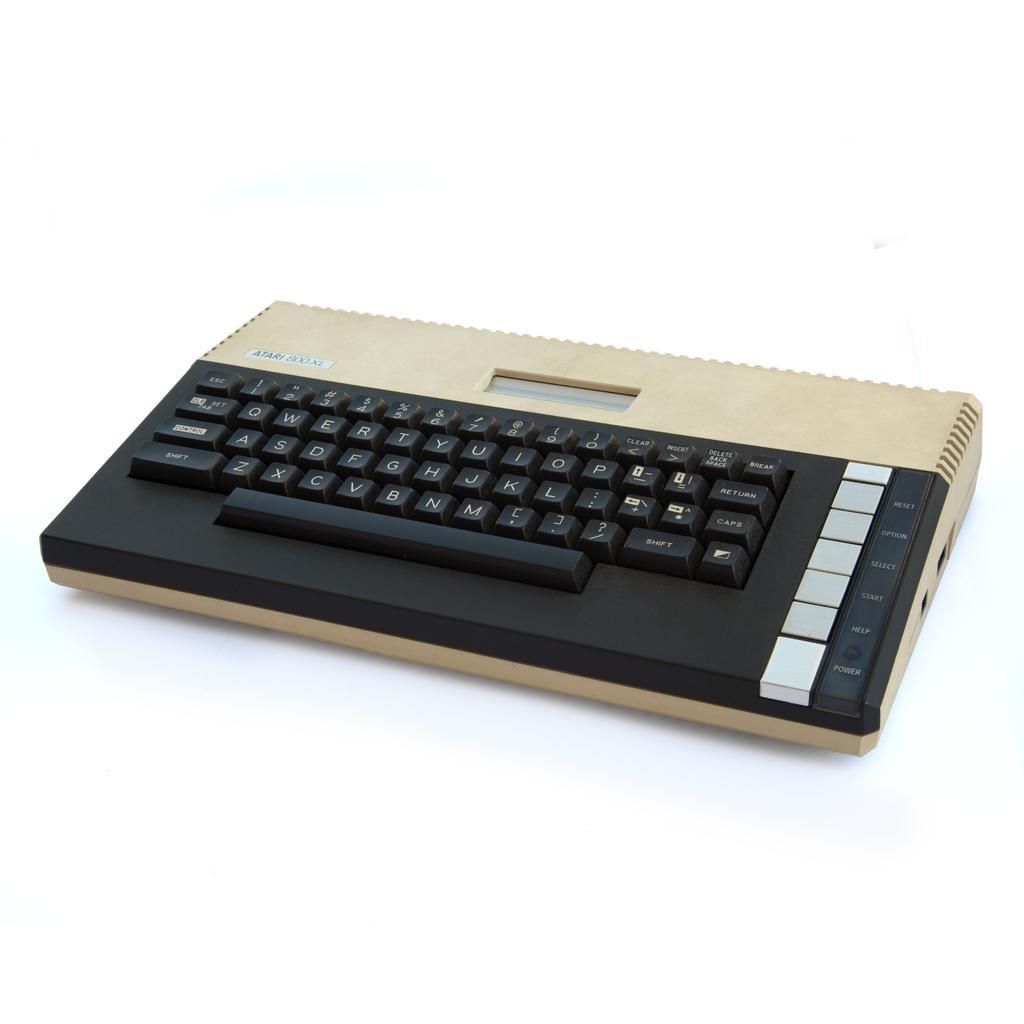<image>
Describe the image concisely. An old Atari 800 XL with a qwerty keyboard. 